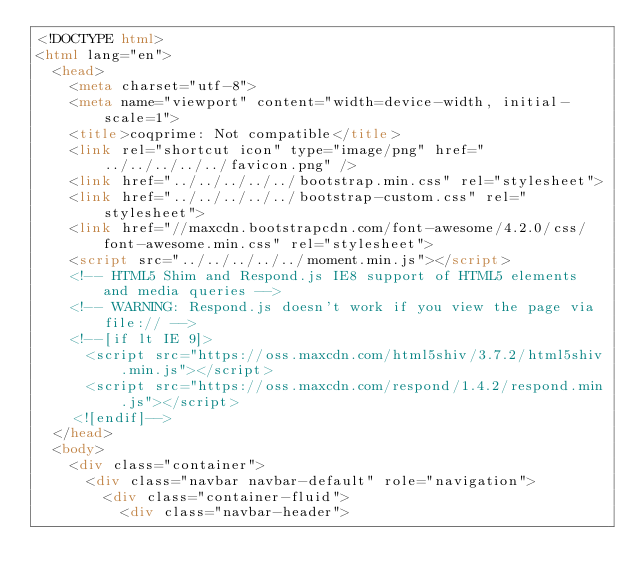<code> <loc_0><loc_0><loc_500><loc_500><_HTML_><!DOCTYPE html>
<html lang="en">
  <head>
    <meta charset="utf-8">
    <meta name="viewport" content="width=device-width, initial-scale=1">
    <title>coqprime: Not compatible</title>
    <link rel="shortcut icon" type="image/png" href="../../../../../favicon.png" />
    <link href="../../../../../bootstrap.min.css" rel="stylesheet">
    <link href="../../../../../bootstrap-custom.css" rel="stylesheet">
    <link href="//maxcdn.bootstrapcdn.com/font-awesome/4.2.0/css/font-awesome.min.css" rel="stylesheet">
    <script src="../../../../../moment.min.js"></script>
    <!-- HTML5 Shim and Respond.js IE8 support of HTML5 elements and media queries -->
    <!-- WARNING: Respond.js doesn't work if you view the page via file:// -->
    <!--[if lt IE 9]>
      <script src="https://oss.maxcdn.com/html5shiv/3.7.2/html5shiv.min.js"></script>
      <script src="https://oss.maxcdn.com/respond/1.4.2/respond.min.js"></script>
    <![endif]-->
  </head>
  <body>
    <div class="container">
      <div class="navbar navbar-default" role="navigation">
        <div class="container-fluid">
          <div class="navbar-header"></code> 